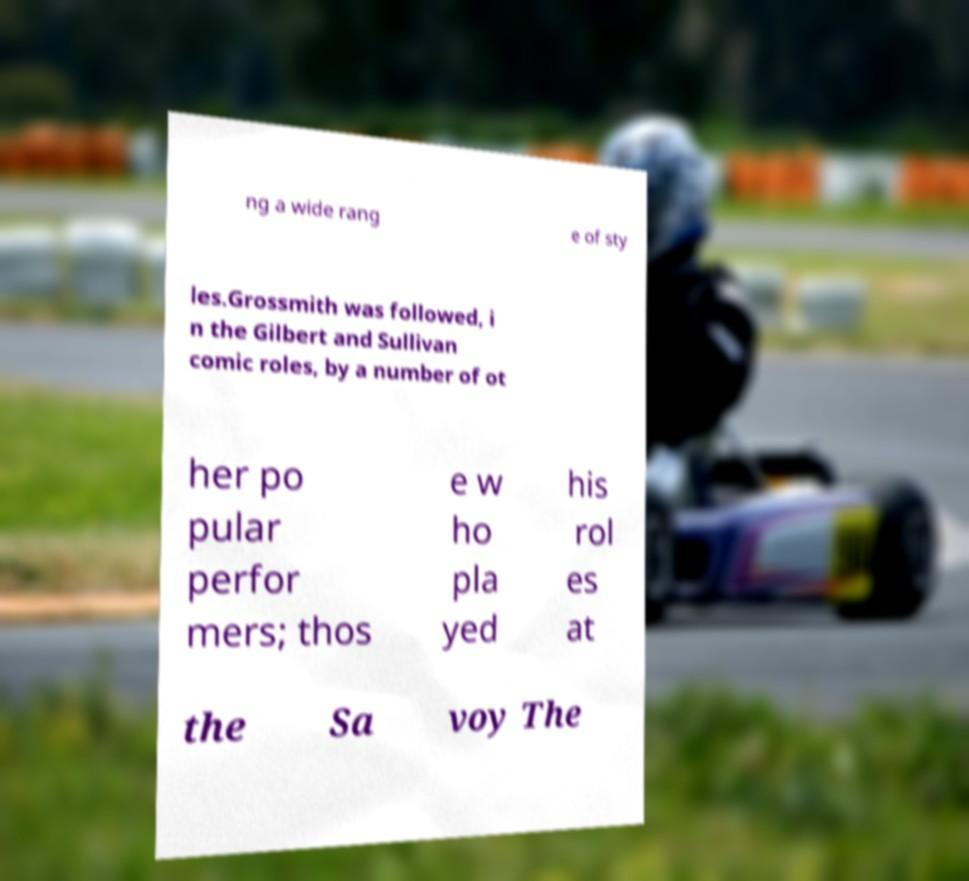I need the written content from this picture converted into text. Can you do that? ng a wide rang e of sty les.Grossmith was followed, i n the Gilbert and Sullivan comic roles, by a number of ot her po pular perfor mers; thos e w ho pla yed his rol es at the Sa voy The 